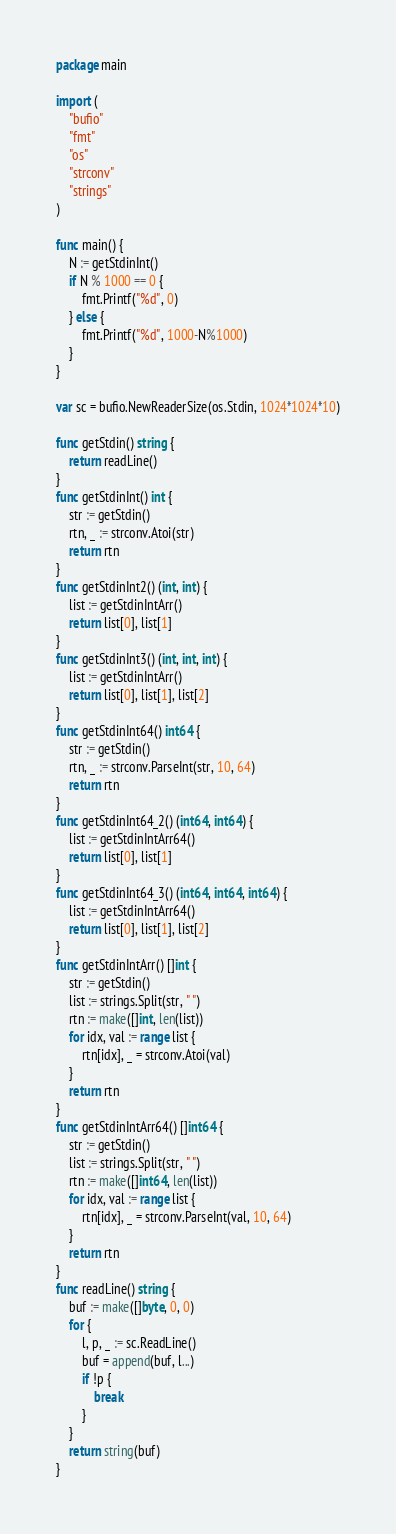<code> <loc_0><loc_0><loc_500><loc_500><_Go_>package main
 
import (
	"bufio"
	"fmt"
	"os"
	"strconv"
	"strings"
)
 
func main() {
	N := getStdinInt()
	if N % 1000 == 0 {
		fmt.Printf("%d", 0)
	} else {
		fmt.Printf("%d", 1000-N%1000)
	}
}
 
var sc = bufio.NewReaderSize(os.Stdin, 1024*1024*10)
 
func getStdin() string {
	return readLine()
}
func getStdinInt() int {
	str := getStdin()
	rtn, _ := strconv.Atoi(str)
	return rtn
}
func getStdinInt2() (int, int) {
	list := getStdinIntArr()
	return list[0], list[1]
}
func getStdinInt3() (int, int, int) {
	list := getStdinIntArr()
	return list[0], list[1], list[2]
}
func getStdinInt64() int64 {
	str := getStdin()
	rtn, _ := strconv.ParseInt(str, 10, 64)
	return rtn
}
func getStdinInt64_2() (int64, int64) {
	list := getStdinIntArr64()
	return list[0], list[1]
}
func getStdinInt64_3() (int64, int64, int64) {
	list := getStdinIntArr64()
	return list[0], list[1], list[2]
}
func getStdinIntArr() []int {
	str := getStdin()
	list := strings.Split(str, " ")
	rtn := make([]int, len(list))
	for idx, val := range list {
		rtn[idx], _ = strconv.Atoi(val)
	}
	return rtn
}
func getStdinIntArr64() []int64 {
	str := getStdin()
	list := strings.Split(str, " ")
	rtn := make([]int64, len(list))
	for idx, val := range list {
		rtn[idx], _ = strconv.ParseInt(val, 10, 64)
	}
	return rtn
}
func readLine() string {
	buf := make([]byte, 0, 0)
	for {
		l, p, _ := sc.ReadLine()
		buf = append(buf, l...)
		if !p {
			break
		}
	}
	return string(buf)
}</code> 